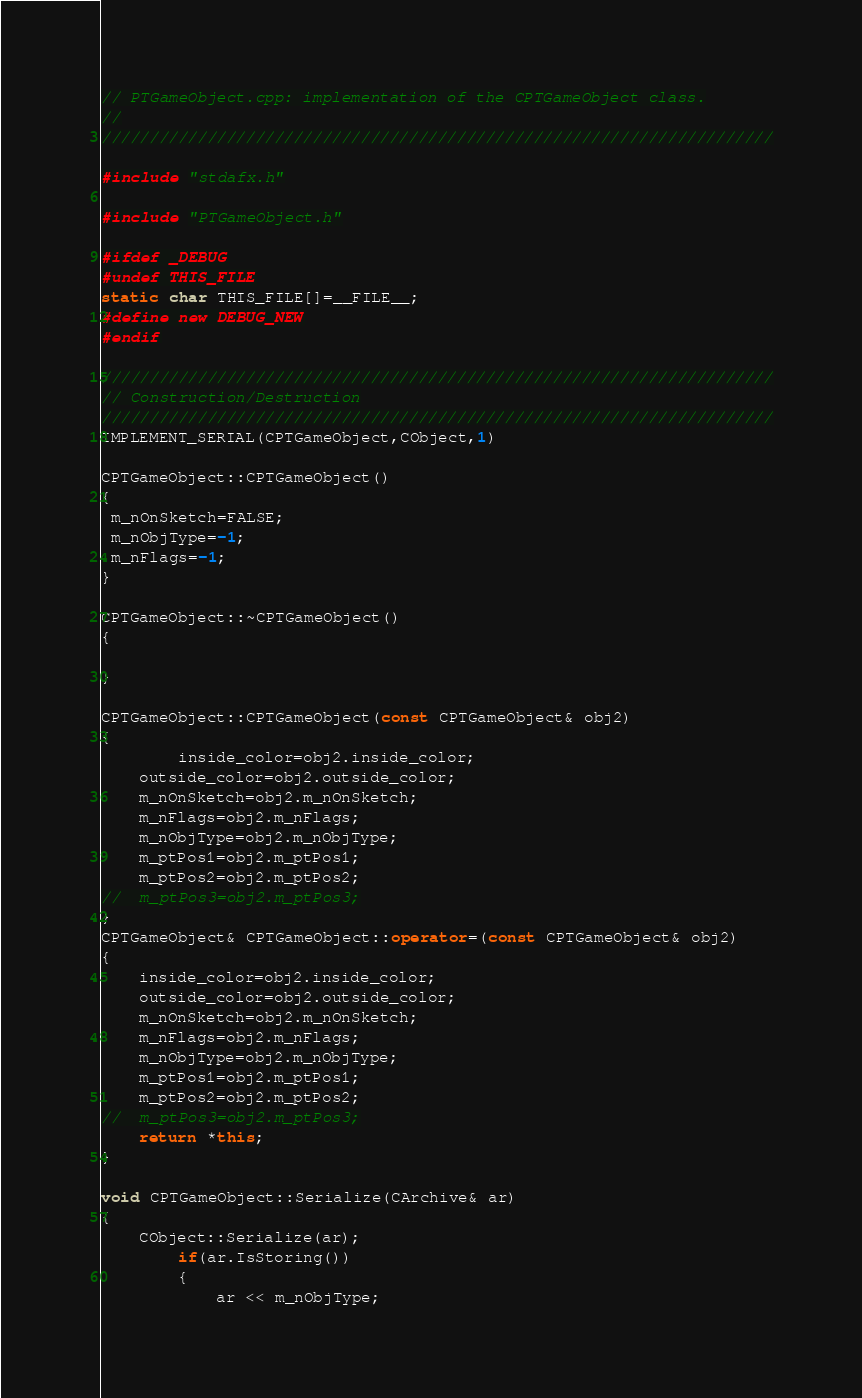<code> <loc_0><loc_0><loc_500><loc_500><_C++_>// PTGameObject.cpp: implementation of the CPTGameObject class.
//
//////////////////////////////////////////////////////////////////////

#include "stdafx.h"

#include "PTGameObject.h"

#ifdef _DEBUG
#undef THIS_FILE
static char THIS_FILE[]=__FILE__;
#define new DEBUG_NEW
#endif

//////////////////////////////////////////////////////////////////////
// Construction/Destruction
//////////////////////////////////////////////////////////////////////
IMPLEMENT_SERIAL(CPTGameObject,CObject,1)

CPTGameObject::CPTGameObject()
{
 m_nOnSketch=FALSE;
 m_nObjType=-1;
 m_nFlags=-1;
}

CPTGameObject::~CPTGameObject()
{

}

CPTGameObject::CPTGameObject(const CPTGameObject& obj2)
{
		inside_color=obj2.inside_color;
	outside_color=obj2.outside_color;
	m_nOnSketch=obj2.m_nOnSketch;
	m_nFlags=obj2.m_nFlags;
	m_nObjType=obj2.m_nObjType;
	m_ptPos1=obj2.m_ptPos1;
	m_ptPos2=obj2.m_ptPos2;
//	m_ptPos3=obj2.m_ptPos3;
}
CPTGameObject& CPTGameObject::operator=(const CPTGameObject& obj2)
{
	inside_color=obj2.inside_color;
	outside_color=obj2.outside_color;
	m_nOnSketch=obj2.m_nOnSketch;
	m_nFlags=obj2.m_nFlags;
	m_nObjType=obj2.m_nObjType;
	m_ptPos1=obj2.m_ptPos1;
	m_ptPos2=obj2.m_ptPos2;
//	m_ptPos3=obj2.m_ptPos3;
	return *this;
}

void CPTGameObject::Serialize(CArchive& ar)
{
	CObject::Serialize(ar);
		if(ar.IsStoring())
		{
			ar << m_nObjType;</code> 